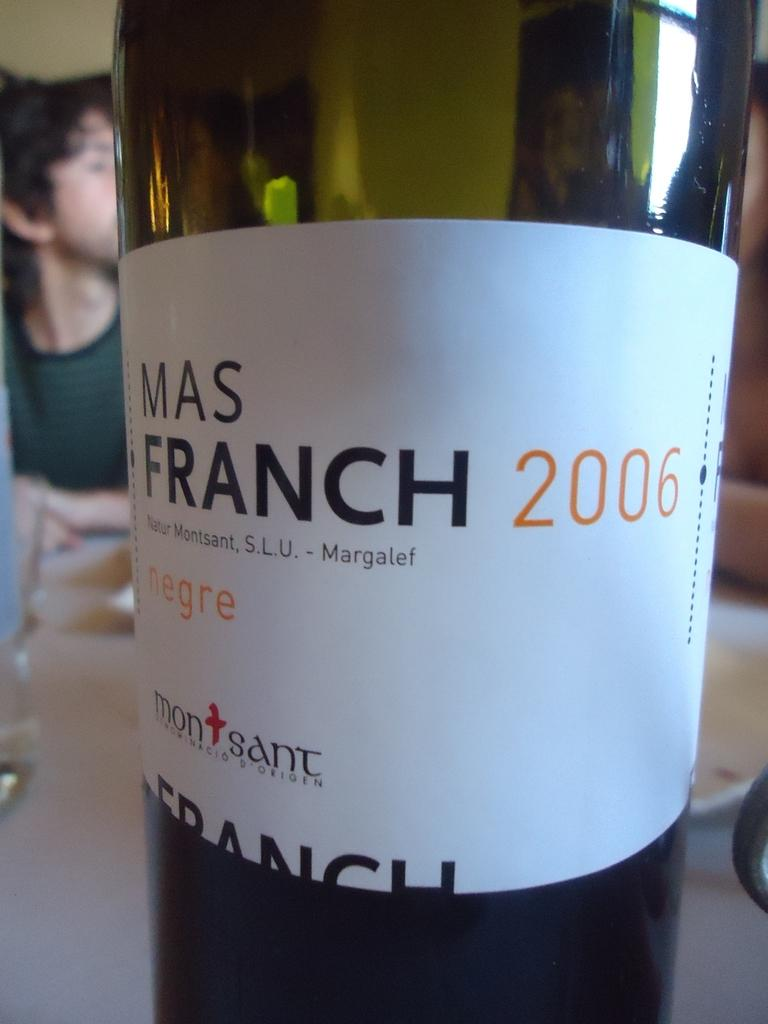<image>
Share a concise interpretation of the image provided. A bottle has the year 2006 on the label with the brand Mas Franch. 